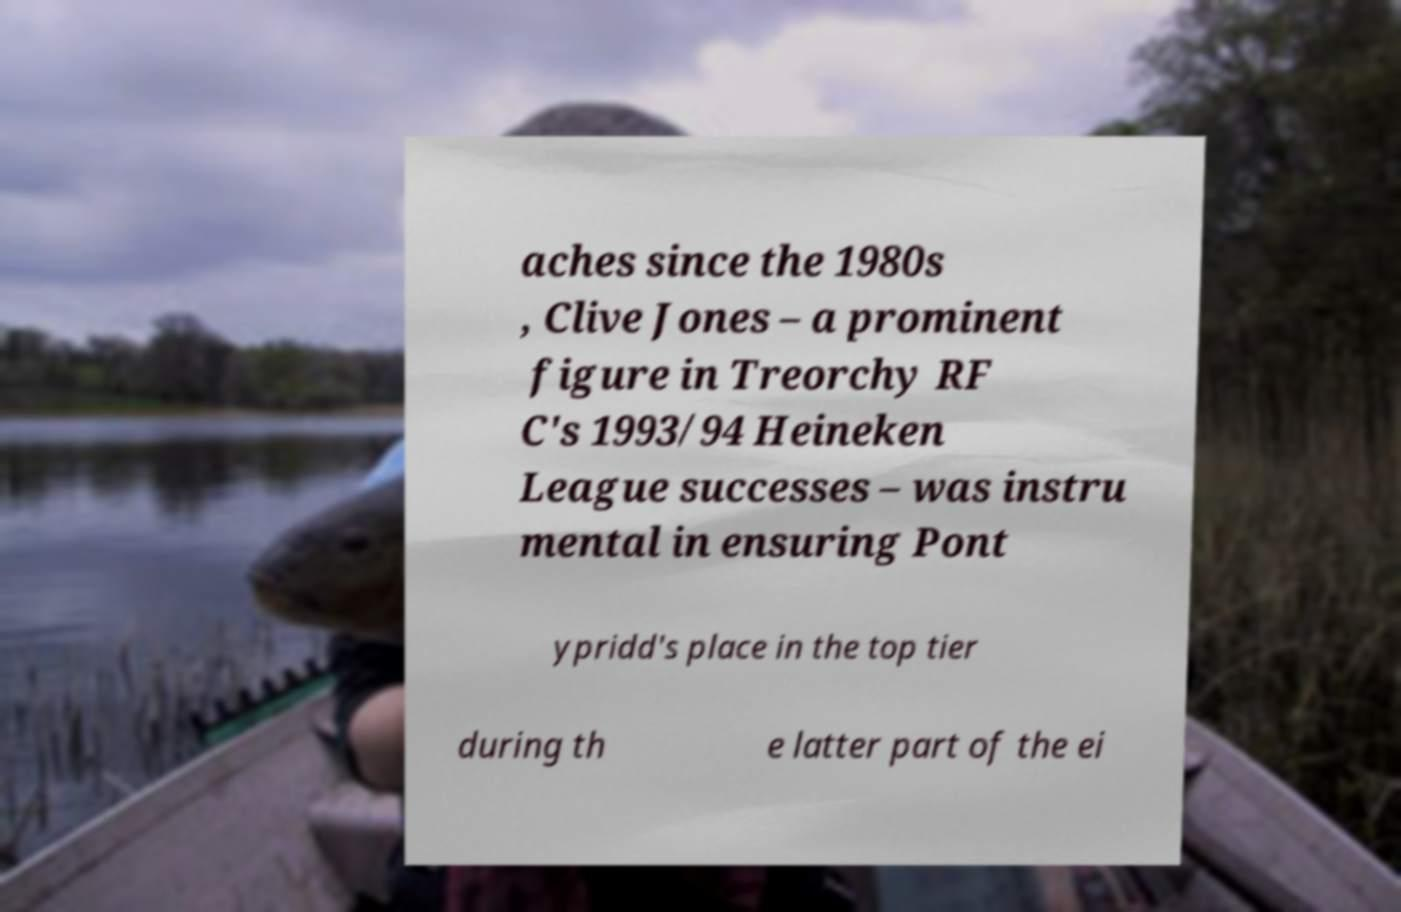What messages or text are displayed in this image? I need them in a readable, typed format. aches since the 1980s , Clive Jones – a prominent figure in Treorchy RF C's 1993/94 Heineken League successes – was instru mental in ensuring Pont ypridd's place in the top tier during th e latter part of the ei 